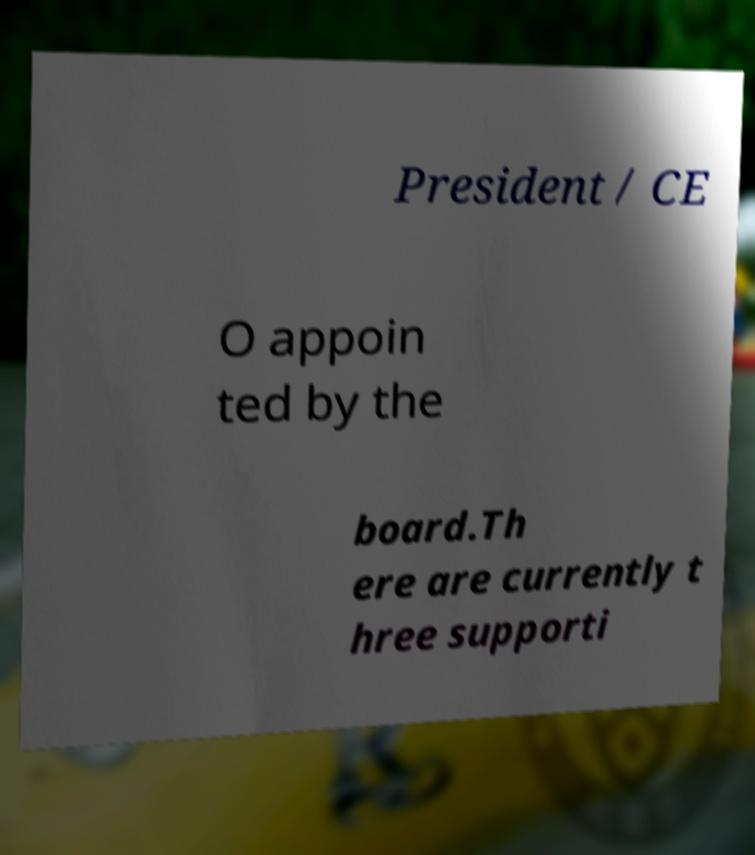Could you assist in decoding the text presented in this image and type it out clearly? President / CE O appoin ted by the board.Th ere are currently t hree supporti 